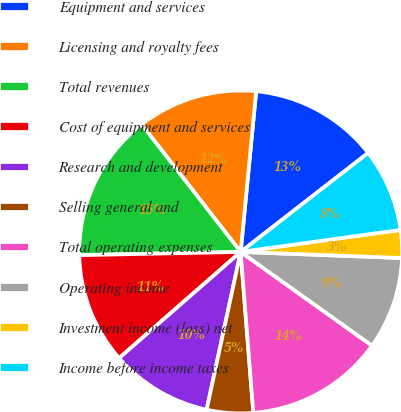<chart> <loc_0><loc_0><loc_500><loc_500><pie_chart><fcel>Equipment and services<fcel>Licensing and royalty fees<fcel>Total revenues<fcel>Cost of equipment and services<fcel>Research and development<fcel>Selling general and<fcel>Total operating expenses<fcel>Operating income<fcel>Investment income (loss) net<fcel>Income before income taxes<nl><fcel>12.96%<fcel>12.04%<fcel>14.81%<fcel>11.11%<fcel>10.19%<fcel>4.63%<fcel>13.89%<fcel>9.26%<fcel>2.78%<fcel>8.33%<nl></chart> 